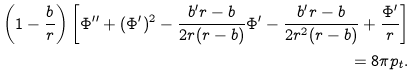<formula> <loc_0><loc_0><loc_500><loc_500>\left ( 1 - \frac { b } { r } \right ) \left [ \Phi ^ { \prime \prime } + ( \Phi ^ { \prime } ) ^ { 2 } - \frac { b ^ { \prime } r - b } { 2 r ( r - b ) } \Phi ^ { \prime } - \frac { b ^ { \prime } r - b } { 2 r ^ { 2 } ( r - b ) } + \frac { \Phi ^ { \prime } } { r } \right ] \\ = 8 \pi p _ { t } .</formula> 